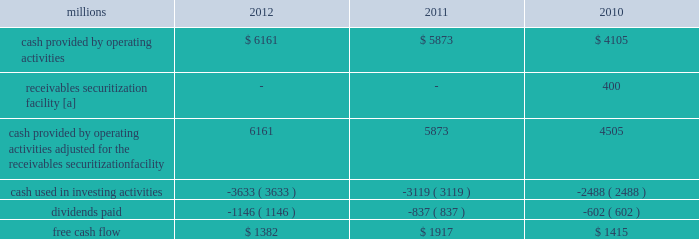F0b7 free cash flow 2013 cash generated by operating activities totaled $ 6.2 billion , reduced by $ 3.6 billion for cash used in investing activities and a 37% ( 37 % ) increase in dividends paid , yielding free cash flow of $ 1.4 billion .
Free cash flow is defined as cash provided by operating activities ( adjusted for the reclassification of our receivables securitization facility ) , less cash used in investing activities and dividends paid .
Free cash flow is not considered a financial measure under accounting principles generally accepted in the u.s .
( gaap ) by sec regulation g and item 10 of sec regulation s-k and may not be defined and calculated by other companies in the same manner .
We believe free cash flow is important to management and investors in evaluating our financial performance and measures our ability to generate cash without additional external financings .
Free cash flow should be considered in addition to , rather than as a substitute for , cash provided by operating activities .
The table reconciles cash provided by operating activities ( gaap measure ) to free cash flow ( non-gaap measure ) : millions 2012 2011 2010 .
[a] effective january 1 , 2010 , a new accounting standard required us to account for receivables transferred under our receivables securitization facility as secured borrowings in our consolidated statements of financial position and as financing activities in our consolidated statements of cash flows .
The receivables securitization facility is included in our free cash flow calculation to adjust cash provided by operating activities as though our receivables securitization facility had been accounted for under the new accounting standard for all periods presented .
2013 outlook f0b7 safety 2013 operating a safe railroad benefits our employees , our customers , our shareholders , and the communities we serve .
We will continue using a multi-faceted approach to safety , utilizing technology , risk assessment , quality control , training and employee engagement , and targeted capital investments .
We will continue using and expanding the deployment of total safety culture throughout our operations , which allows us to identify and implement best practices for employee and operational safety .
Derailment prevention and the reduction of grade crossing incidents are critical aspects of our safety programs .
We will continue our efforts to increase rail defect detection ; improve or close crossings ; and educate the public and law enforcement agencies about crossing safety through a combination of our own programs ( including risk assessment strategies ) , various industry programs and local community activities across our network .
F0b7 network operations 2013 we will continue focusing on our six critical initiatives to improve safety , service and productivity during 2013 .
We are seeing solid contributions from reducing variability , continuous improvements , and standard work .
Resource agility allows us to respond quickly to changing market conditions and network disruptions from weather or other events .
The railroad continues to benefit from capital investments that allow us to build capacity for growth and harden our infrastructure to reduce failure .
F0b7 fuel prices 2013 uncertainty about the economy makes projections of fuel prices difficult .
We again could see volatile fuel prices during the year , as they are sensitive to global and u.s .
Domestic demand , refining capacity , geopolitical events , weather conditions and other factors .
To reduce the impact of fuel price on earnings , we will continue seeking cost recovery from our customers through our fuel surcharge programs and expanding our fuel conservation efforts .
F0b7 capital plan 2013 in 2013 , we plan to make total capital investments of approximately $ 3.6 billion , including expenditures for positive train control ( ptc ) , which may be revised if business conditions warrant or if new laws or regulations affect our ability to generate sufficient returns on these investments .
( see further discussion in this item 7 under liquidity and capital resources 2013 capital plan. ) .
What was the change in free cash flow from 2011 to 2012 , in millions? 
Computations: (1382 - 1917)
Answer: -535.0. 